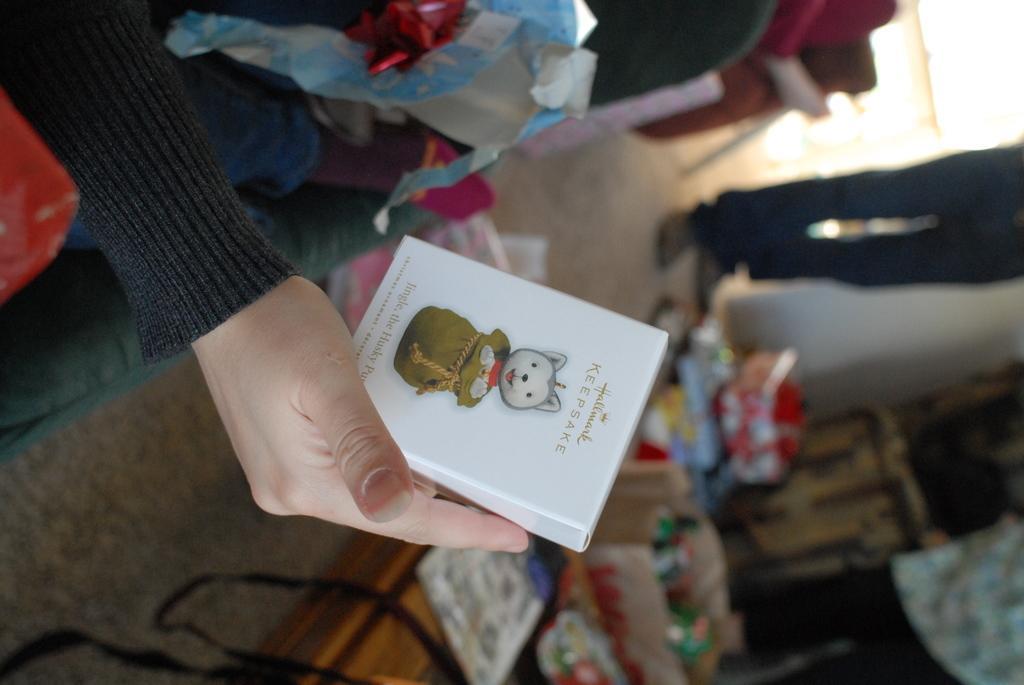Describe this image in one or two sentences. On the right hand side we have a hand who wear ash color dress. In the middle of the image we have box which have cartoon face and some text was written over it and a table which is blurred. On the left side we have a person and some gifts which are blurred. 